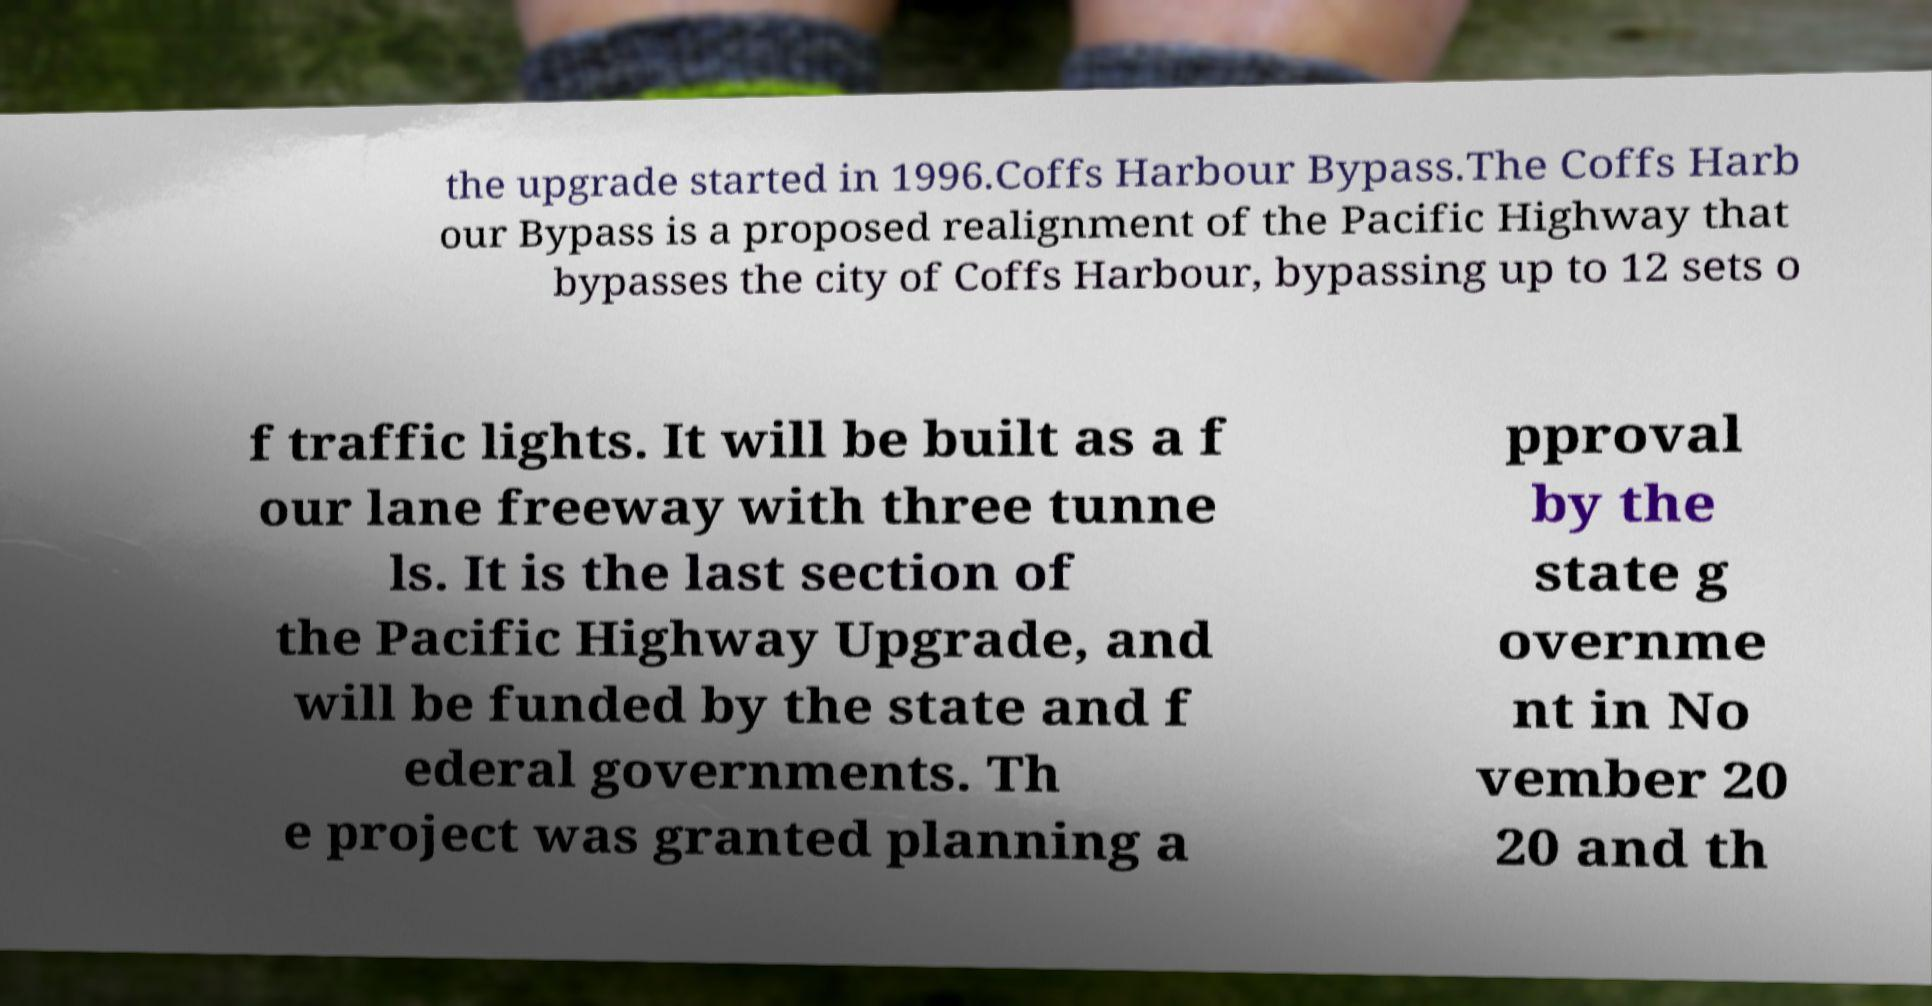Please identify and transcribe the text found in this image. the upgrade started in 1996.Coffs Harbour Bypass.The Coffs Harb our Bypass is a proposed realignment of the Pacific Highway that bypasses the city of Coffs Harbour, bypassing up to 12 sets o f traffic lights. It will be built as a f our lane freeway with three tunne ls. It is the last section of the Pacific Highway Upgrade, and will be funded by the state and f ederal governments. Th e project was granted planning a pproval by the state g overnme nt in No vember 20 20 and th 